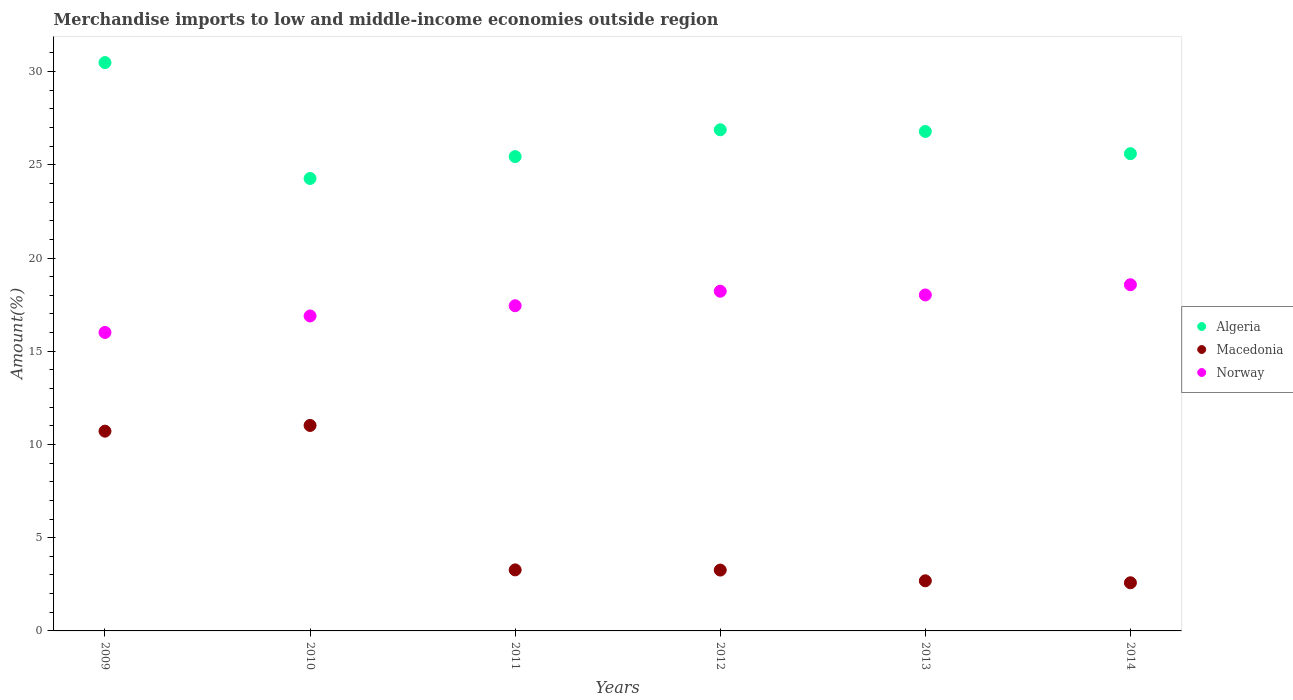What is the percentage of amount earned from merchandise imports in Norway in 2012?
Ensure brevity in your answer.  18.22. Across all years, what is the maximum percentage of amount earned from merchandise imports in Norway?
Give a very brief answer. 18.57. Across all years, what is the minimum percentage of amount earned from merchandise imports in Norway?
Give a very brief answer. 16.01. In which year was the percentage of amount earned from merchandise imports in Macedonia maximum?
Ensure brevity in your answer.  2010. What is the total percentage of amount earned from merchandise imports in Macedonia in the graph?
Keep it short and to the point. 33.54. What is the difference between the percentage of amount earned from merchandise imports in Norway in 2009 and that in 2011?
Provide a short and direct response. -1.43. What is the difference between the percentage of amount earned from merchandise imports in Macedonia in 2013 and the percentage of amount earned from merchandise imports in Algeria in 2009?
Ensure brevity in your answer.  -27.8. What is the average percentage of amount earned from merchandise imports in Macedonia per year?
Offer a terse response. 5.59. In the year 2012, what is the difference between the percentage of amount earned from merchandise imports in Macedonia and percentage of amount earned from merchandise imports in Algeria?
Your response must be concise. -23.62. In how many years, is the percentage of amount earned from merchandise imports in Algeria greater than 20 %?
Ensure brevity in your answer.  6. What is the ratio of the percentage of amount earned from merchandise imports in Norway in 2011 to that in 2013?
Your response must be concise. 0.97. Is the difference between the percentage of amount earned from merchandise imports in Macedonia in 2011 and 2014 greater than the difference between the percentage of amount earned from merchandise imports in Algeria in 2011 and 2014?
Make the answer very short. Yes. What is the difference between the highest and the second highest percentage of amount earned from merchandise imports in Norway?
Provide a succinct answer. 0.35. What is the difference between the highest and the lowest percentage of amount earned from merchandise imports in Norway?
Provide a short and direct response. 2.56. Does the percentage of amount earned from merchandise imports in Algeria monotonically increase over the years?
Give a very brief answer. No. Is the percentage of amount earned from merchandise imports in Norway strictly greater than the percentage of amount earned from merchandise imports in Algeria over the years?
Your response must be concise. No. How many years are there in the graph?
Keep it short and to the point. 6. Are the values on the major ticks of Y-axis written in scientific E-notation?
Your answer should be compact. No. Does the graph contain any zero values?
Your response must be concise. No. How many legend labels are there?
Keep it short and to the point. 3. How are the legend labels stacked?
Keep it short and to the point. Vertical. What is the title of the graph?
Your response must be concise. Merchandise imports to low and middle-income economies outside region. Does "Liberia" appear as one of the legend labels in the graph?
Keep it short and to the point. No. What is the label or title of the Y-axis?
Provide a short and direct response. Amount(%). What is the Amount(%) in Algeria in 2009?
Keep it short and to the point. 30.48. What is the Amount(%) in Macedonia in 2009?
Keep it short and to the point. 10.71. What is the Amount(%) of Norway in 2009?
Provide a short and direct response. 16.01. What is the Amount(%) in Algeria in 2010?
Your answer should be compact. 24.27. What is the Amount(%) of Macedonia in 2010?
Provide a succinct answer. 11.02. What is the Amount(%) of Norway in 2010?
Your answer should be compact. 16.89. What is the Amount(%) in Algeria in 2011?
Your answer should be compact. 25.44. What is the Amount(%) in Macedonia in 2011?
Ensure brevity in your answer.  3.27. What is the Amount(%) in Norway in 2011?
Your response must be concise. 17.44. What is the Amount(%) in Algeria in 2012?
Make the answer very short. 26.88. What is the Amount(%) in Macedonia in 2012?
Give a very brief answer. 3.26. What is the Amount(%) in Norway in 2012?
Offer a very short reply. 18.22. What is the Amount(%) in Algeria in 2013?
Give a very brief answer. 26.79. What is the Amount(%) in Macedonia in 2013?
Offer a very short reply. 2.69. What is the Amount(%) of Norway in 2013?
Give a very brief answer. 18.02. What is the Amount(%) in Algeria in 2014?
Provide a succinct answer. 25.6. What is the Amount(%) of Macedonia in 2014?
Provide a succinct answer. 2.58. What is the Amount(%) in Norway in 2014?
Your answer should be compact. 18.57. Across all years, what is the maximum Amount(%) of Algeria?
Provide a short and direct response. 30.48. Across all years, what is the maximum Amount(%) in Macedonia?
Your answer should be compact. 11.02. Across all years, what is the maximum Amount(%) of Norway?
Your response must be concise. 18.57. Across all years, what is the minimum Amount(%) of Algeria?
Keep it short and to the point. 24.27. Across all years, what is the minimum Amount(%) of Macedonia?
Make the answer very short. 2.58. Across all years, what is the minimum Amount(%) of Norway?
Your answer should be very brief. 16.01. What is the total Amount(%) in Algeria in the graph?
Give a very brief answer. 159.47. What is the total Amount(%) of Macedonia in the graph?
Your response must be concise. 33.54. What is the total Amount(%) in Norway in the graph?
Offer a very short reply. 105.16. What is the difference between the Amount(%) in Algeria in 2009 and that in 2010?
Your response must be concise. 6.22. What is the difference between the Amount(%) in Macedonia in 2009 and that in 2010?
Give a very brief answer. -0.31. What is the difference between the Amount(%) in Norway in 2009 and that in 2010?
Provide a succinct answer. -0.88. What is the difference between the Amount(%) in Algeria in 2009 and that in 2011?
Give a very brief answer. 5.04. What is the difference between the Amount(%) in Macedonia in 2009 and that in 2011?
Your response must be concise. 7.44. What is the difference between the Amount(%) of Norway in 2009 and that in 2011?
Offer a terse response. -1.43. What is the difference between the Amount(%) of Algeria in 2009 and that in 2012?
Offer a very short reply. 3.6. What is the difference between the Amount(%) in Macedonia in 2009 and that in 2012?
Give a very brief answer. 7.45. What is the difference between the Amount(%) in Norway in 2009 and that in 2012?
Make the answer very short. -2.21. What is the difference between the Amount(%) of Algeria in 2009 and that in 2013?
Your answer should be very brief. 3.69. What is the difference between the Amount(%) in Macedonia in 2009 and that in 2013?
Provide a short and direct response. 8.03. What is the difference between the Amount(%) in Norway in 2009 and that in 2013?
Make the answer very short. -2.01. What is the difference between the Amount(%) in Algeria in 2009 and that in 2014?
Ensure brevity in your answer.  4.89. What is the difference between the Amount(%) of Macedonia in 2009 and that in 2014?
Ensure brevity in your answer.  8.13. What is the difference between the Amount(%) of Norway in 2009 and that in 2014?
Your answer should be very brief. -2.56. What is the difference between the Amount(%) of Algeria in 2010 and that in 2011?
Your answer should be compact. -1.17. What is the difference between the Amount(%) in Macedonia in 2010 and that in 2011?
Your answer should be compact. 7.75. What is the difference between the Amount(%) of Norway in 2010 and that in 2011?
Provide a succinct answer. -0.55. What is the difference between the Amount(%) of Algeria in 2010 and that in 2012?
Provide a succinct answer. -2.61. What is the difference between the Amount(%) of Macedonia in 2010 and that in 2012?
Keep it short and to the point. 7.76. What is the difference between the Amount(%) in Norway in 2010 and that in 2012?
Ensure brevity in your answer.  -1.33. What is the difference between the Amount(%) in Algeria in 2010 and that in 2013?
Offer a very short reply. -2.52. What is the difference between the Amount(%) in Macedonia in 2010 and that in 2013?
Your response must be concise. 8.33. What is the difference between the Amount(%) of Norway in 2010 and that in 2013?
Your answer should be compact. -1.13. What is the difference between the Amount(%) of Algeria in 2010 and that in 2014?
Give a very brief answer. -1.33. What is the difference between the Amount(%) in Macedonia in 2010 and that in 2014?
Make the answer very short. 8.44. What is the difference between the Amount(%) in Norway in 2010 and that in 2014?
Make the answer very short. -1.68. What is the difference between the Amount(%) of Algeria in 2011 and that in 2012?
Give a very brief answer. -1.44. What is the difference between the Amount(%) of Macedonia in 2011 and that in 2012?
Your response must be concise. 0.01. What is the difference between the Amount(%) of Norway in 2011 and that in 2012?
Your answer should be compact. -0.78. What is the difference between the Amount(%) in Algeria in 2011 and that in 2013?
Your response must be concise. -1.35. What is the difference between the Amount(%) in Macedonia in 2011 and that in 2013?
Provide a short and direct response. 0.59. What is the difference between the Amount(%) in Norway in 2011 and that in 2013?
Your answer should be compact. -0.58. What is the difference between the Amount(%) of Algeria in 2011 and that in 2014?
Provide a succinct answer. -0.16. What is the difference between the Amount(%) in Macedonia in 2011 and that in 2014?
Ensure brevity in your answer.  0.69. What is the difference between the Amount(%) of Norway in 2011 and that in 2014?
Make the answer very short. -1.13. What is the difference between the Amount(%) in Algeria in 2012 and that in 2013?
Offer a terse response. 0.09. What is the difference between the Amount(%) of Macedonia in 2012 and that in 2013?
Ensure brevity in your answer.  0.58. What is the difference between the Amount(%) in Norway in 2012 and that in 2013?
Offer a terse response. 0.2. What is the difference between the Amount(%) of Algeria in 2012 and that in 2014?
Make the answer very short. 1.28. What is the difference between the Amount(%) of Macedonia in 2012 and that in 2014?
Your response must be concise. 0.68. What is the difference between the Amount(%) of Norway in 2012 and that in 2014?
Offer a very short reply. -0.35. What is the difference between the Amount(%) of Algeria in 2013 and that in 2014?
Make the answer very short. 1.19. What is the difference between the Amount(%) in Macedonia in 2013 and that in 2014?
Provide a short and direct response. 0.11. What is the difference between the Amount(%) in Norway in 2013 and that in 2014?
Your response must be concise. -0.55. What is the difference between the Amount(%) of Algeria in 2009 and the Amount(%) of Macedonia in 2010?
Your answer should be compact. 19.46. What is the difference between the Amount(%) in Algeria in 2009 and the Amount(%) in Norway in 2010?
Your response must be concise. 13.59. What is the difference between the Amount(%) of Macedonia in 2009 and the Amount(%) of Norway in 2010?
Your answer should be compact. -6.18. What is the difference between the Amount(%) in Algeria in 2009 and the Amount(%) in Macedonia in 2011?
Give a very brief answer. 27.21. What is the difference between the Amount(%) in Algeria in 2009 and the Amount(%) in Norway in 2011?
Your answer should be compact. 13.04. What is the difference between the Amount(%) in Macedonia in 2009 and the Amount(%) in Norway in 2011?
Provide a short and direct response. -6.73. What is the difference between the Amount(%) in Algeria in 2009 and the Amount(%) in Macedonia in 2012?
Ensure brevity in your answer.  27.22. What is the difference between the Amount(%) in Algeria in 2009 and the Amount(%) in Norway in 2012?
Your response must be concise. 12.26. What is the difference between the Amount(%) of Macedonia in 2009 and the Amount(%) of Norway in 2012?
Your answer should be very brief. -7.51. What is the difference between the Amount(%) in Algeria in 2009 and the Amount(%) in Macedonia in 2013?
Offer a terse response. 27.8. What is the difference between the Amount(%) of Algeria in 2009 and the Amount(%) of Norway in 2013?
Provide a short and direct response. 12.46. What is the difference between the Amount(%) in Macedonia in 2009 and the Amount(%) in Norway in 2013?
Provide a short and direct response. -7.31. What is the difference between the Amount(%) of Algeria in 2009 and the Amount(%) of Macedonia in 2014?
Your answer should be very brief. 27.9. What is the difference between the Amount(%) in Algeria in 2009 and the Amount(%) in Norway in 2014?
Provide a succinct answer. 11.92. What is the difference between the Amount(%) in Macedonia in 2009 and the Amount(%) in Norway in 2014?
Ensure brevity in your answer.  -7.85. What is the difference between the Amount(%) in Algeria in 2010 and the Amount(%) in Macedonia in 2011?
Give a very brief answer. 20.99. What is the difference between the Amount(%) of Algeria in 2010 and the Amount(%) of Norway in 2011?
Offer a terse response. 6.83. What is the difference between the Amount(%) in Macedonia in 2010 and the Amount(%) in Norway in 2011?
Offer a terse response. -6.42. What is the difference between the Amount(%) of Algeria in 2010 and the Amount(%) of Macedonia in 2012?
Your answer should be very brief. 21. What is the difference between the Amount(%) in Algeria in 2010 and the Amount(%) in Norway in 2012?
Offer a very short reply. 6.05. What is the difference between the Amount(%) in Macedonia in 2010 and the Amount(%) in Norway in 2012?
Make the answer very short. -7.2. What is the difference between the Amount(%) in Algeria in 2010 and the Amount(%) in Macedonia in 2013?
Give a very brief answer. 21.58. What is the difference between the Amount(%) of Algeria in 2010 and the Amount(%) of Norway in 2013?
Give a very brief answer. 6.25. What is the difference between the Amount(%) in Macedonia in 2010 and the Amount(%) in Norway in 2013?
Your answer should be compact. -7. What is the difference between the Amount(%) in Algeria in 2010 and the Amount(%) in Macedonia in 2014?
Provide a succinct answer. 21.68. What is the difference between the Amount(%) in Algeria in 2010 and the Amount(%) in Norway in 2014?
Give a very brief answer. 5.7. What is the difference between the Amount(%) of Macedonia in 2010 and the Amount(%) of Norway in 2014?
Provide a short and direct response. -7.55. What is the difference between the Amount(%) in Algeria in 2011 and the Amount(%) in Macedonia in 2012?
Your answer should be compact. 22.18. What is the difference between the Amount(%) of Algeria in 2011 and the Amount(%) of Norway in 2012?
Keep it short and to the point. 7.22. What is the difference between the Amount(%) in Macedonia in 2011 and the Amount(%) in Norway in 2012?
Make the answer very short. -14.95. What is the difference between the Amount(%) in Algeria in 2011 and the Amount(%) in Macedonia in 2013?
Give a very brief answer. 22.75. What is the difference between the Amount(%) in Algeria in 2011 and the Amount(%) in Norway in 2013?
Provide a short and direct response. 7.42. What is the difference between the Amount(%) in Macedonia in 2011 and the Amount(%) in Norway in 2013?
Provide a succinct answer. -14.75. What is the difference between the Amount(%) of Algeria in 2011 and the Amount(%) of Macedonia in 2014?
Offer a very short reply. 22.86. What is the difference between the Amount(%) of Algeria in 2011 and the Amount(%) of Norway in 2014?
Your response must be concise. 6.87. What is the difference between the Amount(%) in Macedonia in 2011 and the Amount(%) in Norway in 2014?
Ensure brevity in your answer.  -15.3. What is the difference between the Amount(%) in Algeria in 2012 and the Amount(%) in Macedonia in 2013?
Your answer should be compact. 24.19. What is the difference between the Amount(%) in Algeria in 2012 and the Amount(%) in Norway in 2013?
Offer a very short reply. 8.86. What is the difference between the Amount(%) of Macedonia in 2012 and the Amount(%) of Norway in 2013?
Offer a very short reply. -14.76. What is the difference between the Amount(%) in Algeria in 2012 and the Amount(%) in Macedonia in 2014?
Keep it short and to the point. 24.3. What is the difference between the Amount(%) of Algeria in 2012 and the Amount(%) of Norway in 2014?
Provide a short and direct response. 8.31. What is the difference between the Amount(%) in Macedonia in 2012 and the Amount(%) in Norway in 2014?
Keep it short and to the point. -15.31. What is the difference between the Amount(%) in Algeria in 2013 and the Amount(%) in Macedonia in 2014?
Offer a terse response. 24.21. What is the difference between the Amount(%) in Algeria in 2013 and the Amount(%) in Norway in 2014?
Provide a succinct answer. 8.22. What is the difference between the Amount(%) in Macedonia in 2013 and the Amount(%) in Norway in 2014?
Offer a terse response. -15.88. What is the average Amount(%) in Algeria per year?
Ensure brevity in your answer.  26.58. What is the average Amount(%) in Macedonia per year?
Provide a short and direct response. 5.59. What is the average Amount(%) in Norway per year?
Ensure brevity in your answer.  17.53. In the year 2009, what is the difference between the Amount(%) in Algeria and Amount(%) in Macedonia?
Provide a short and direct response. 19.77. In the year 2009, what is the difference between the Amount(%) in Algeria and Amount(%) in Norway?
Provide a short and direct response. 14.47. In the year 2009, what is the difference between the Amount(%) of Macedonia and Amount(%) of Norway?
Give a very brief answer. -5.3. In the year 2010, what is the difference between the Amount(%) in Algeria and Amount(%) in Macedonia?
Make the answer very short. 13.25. In the year 2010, what is the difference between the Amount(%) of Algeria and Amount(%) of Norway?
Provide a succinct answer. 7.37. In the year 2010, what is the difference between the Amount(%) of Macedonia and Amount(%) of Norway?
Ensure brevity in your answer.  -5.87. In the year 2011, what is the difference between the Amount(%) of Algeria and Amount(%) of Macedonia?
Provide a short and direct response. 22.17. In the year 2011, what is the difference between the Amount(%) in Algeria and Amount(%) in Norway?
Your answer should be very brief. 8. In the year 2011, what is the difference between the Amount(%) in Macedonia and Amount(%) in Norway?
Keep it short and to the point. -14.17. In the year 2012, what is the difference between the Amount(%) in Algeria and Amount(%) in Macedonia?
Ensure brevity in your answer.  23.62. In the year 2012, what is the difference between the Amount(%) of Algeria and Amount(%) of Norway?
Your answer should be compact. 8.66. In the year 2012, what is the difference between the Amount(%) in Macedonia and Amount(%) in Norway?
Provide a short and direct response. -14.96. In the year 2013, what is the difference between the Amount(%) in Algeria and Amount(%) in Macedonia?
Offer a very short reply. 24.1. In the year 2013, what is the difference between the Amount(%) in Algeria and Amount(%) in Norway?
Ensure brevity in your answer.  8.77. In the year 2013, what is the difference between the Amount(%) in Macedonia and Amount(%) in Norway?
Your answer should be compact. -15.33. In the year 2014, what is the difference between the Amount(%) of Algeria and Amount(%) of Macedonia?
Your response must be concise. 23.02. In the year 2014, what is the difference between the Amount(%) in Algeria and Amount(%) in Norway?
Provide a short and direct response. 7.03. In the year 2014, what is the difference between the Amount(%) of Macedonia and Amount(%) of Norway?
Ensure brevity in your answer.  -15.99. What is the ratio of the Amount(%) of Algeria in 2009 to that in 2010?
Make the answer very short. 1.26. What is the ratio of the Amount(%) of Macedonia in 2009 to that in 2010?
Offer a very short reply. 0.97. What is the ratio of the Amount(%) in Norway in 2009 to that in 2010?
Your answer should be very brief. 0.95. What is the ratio of the Amount(%) of Algeria in 2009 to that in 2011?
Give a very brief answer. 1.2. What is the ratio of the Amount(%) in Macedonia in 2009 to that in 2011?
Ensure brevity in your answer.  3.27. What is the ratio of the Amount(%) in Norway in 2009 to that in 2011?
Make the answer very short. 0.92. What is the ratio of the Amount(%) in Algeria in 2009 to that in 2012?
Your response must be concise. 1.13. What is the ratio of the Amount(%) of Macedonia in 2009 to that in 2012?
Offer a terse response. 3.28. What is the ratio of the Amount(%) of Norway in 2009 to that in 2012?
Ensure brevity in your answer.  0.88. What is the ratio of the Amount(%) of Algeria in 2009 to that in 2013?
Your answer should be compact. 1.14. What is the ratio of the Amount(%) of Macedonia in 2009 to that in 2013?
Provide a short and direct response. 3.99. What is the ratio of the Amount(%) in Norway in 2009 to that in 2013?
Ensure brevity in your answer.  0.89. What is the ratio of the Amount(%) of Algeria in 2009 to that in 2014?
Give a very brief answer. 1.19. What is the ratio of the Amount(%) of Macedonia in 2009 to that in 2014?
Offer a very short reply. 4.15. What is the ratio of the Amount(%) of Norway in 2009 to that in 2014?
Ensure brevity in your answer.  0.86. What is the ratio of the Amount(%) in Algeria in 2010 to that in 2011?
Provide a succinct answer. 0.95. What is the ratio of the Amount(%) in Macedonia in 2010 to that in 2011?
Your response must be concise. 3.37. What is the ratio of the Amount(%) of Norway in 2010 to that in 2011?
Make the answer very short. 0.97. What is the ratio of the Amount(%) of Algeria in 2010 to that in 2012?
Offer a terse response. 0.9. What is the ratio of the Amount(%) of Macedonia in 2010 to that in 2012?
Your answer should be compact. 3.38. What is the ratio of the Amount(%) of Norway in 2010 to that in 2012?
Ensure brevity in your answer.  0.93. What is the ratio of the Amount(%) of Algeria in 2010 to that in 2013?
Your answer should be compact. 0.91. What is the ratio of the Amount(%) in Macedonia in 2010 to that in 2013?
Offer a terse response. 4.1. What is the ratio of the Amount(%) of Norway in 2010 to that in 2013?
Give a very brief answer. 0.94. What is the ratio of the Amount(%) in Algeria in 2010 to that in 2014?
Keep it short and to the point. 0.95. What is the ratio of the Amount(%) in Macedonia in 2010 to that in 2014?
Make the answer very short. 4.27. What is the ratio of the Amount(%) of Norway in 2010 to that in 2014?
Offer a very short reply. 0.91. What is the ratio of the Amount(%) in Algeria in 2011 to that in 2012?
Your answer should be very brief. 0.95. What is the ratio of the Amount(%) in Norway in 2011 to that in 2012?
Provide a succinct answer. 0.96. What is the ratio of the Amount(%) in Algeria in 2011 to that in 2013?
Your response must be concise. 0.95. What is the ratio of the Amount(%) of Macedonia in 2011 to that in 2013?
Offer a terse response. 1.22. What is the ratio of the Amount(%) in Norway in 2011 to that in 2013?
Offer a very short reply. 0.97. What is the ratio of the Amount(%) of Macedonia in 2011 to that in 2014?
Provide a succinct answer. 1.27. What is the ratio of the Amount(%) of Norway in 2011 to that in 2014?
Your answer should be compact. 0.94. What is the ratio of the Amount(%) in Macedonia in 2012 to that in 2013?
Your response must be concise. 1.21. What is the ratio of the Amount(%) in Norway in 2012 to that in 2013?
Keep it short and to the point. 1.01. What is the ratio of the Amount(%) in Macedonia in 2012 to that in 2014?
Provide a short and direct response. 1.26. What is the ratio of the Amount(%) in Norway in 2012 to that in 2014?
Offer a terse response. 0.98. What is the ratio of the Amount(%) of Algeria in 2013 to that in 2014?
Keep it short and to the point. 1.05. What is the ratio of the Amount(%) in Macedonia in 2013 to that in 2014?
Provide a short and direct response. 1.04. What is the ratio of the Amount(%) in Norway in 2013 to that in 2014?
Your answer should be compact. 0.97. What is the difference between the highest and the second highest Amount(%) of Algeria?
Make the answer very short. 3.6. What is the difference between the highest and the second highest Amount(%) in Macedonia?
Your answer should be very brief. 0.31. What is the difference between the highest and the second highest Amount(%) in Norway?
Provide a succinct answer. 0.35. What is the difference between the highest and the lowest Amount(%) in Algeria?
Your answer should be compact. 6.22. What is the difference between the highest and the lowest Amount(%) of Macedonia?
Your answer should be compact. 8.44. What is the difference between the highest and the lowest Amount(%) of Norway?
Provide a short and direct response. 2.56. 